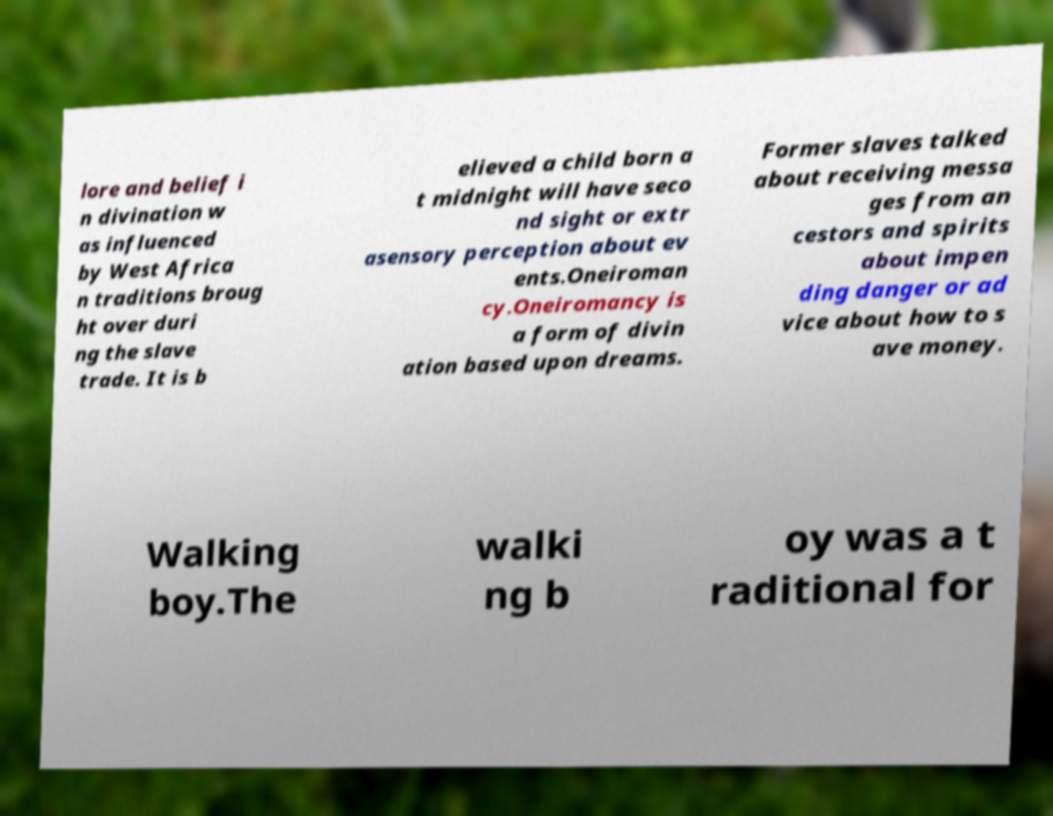Can you read and provide the text displayed in the image?This photo seems to have some interesting text. Can you extract and type it out for me? lore and belief i n divination w as influenced by West Africa n traditions broug ht over duri ng the slave trade. It is b elieved a child born a t midnight will have seco nd sight or extr asensory perception about ev ents.Oneiroman cy.Oneiromancy is a form of divin ation based upon dreams. Former slaves talked about receiving messa ges from an cestors and spirits about impen ding danger or ad vice about how to s ave money. Walking boy.The walki ng b oy was a t raditional for 